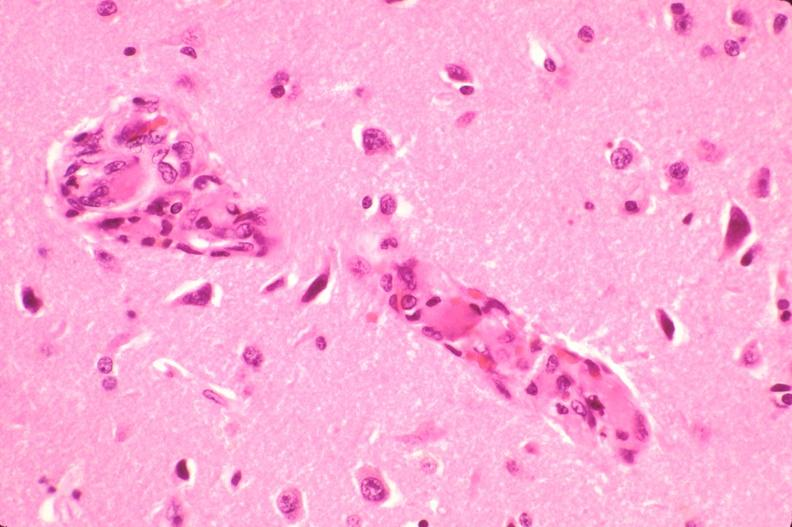does this image show brain, microthrombi, thrombotic thrombocytopenic purpura?
Answer the question using a single word or phrase. Yes 